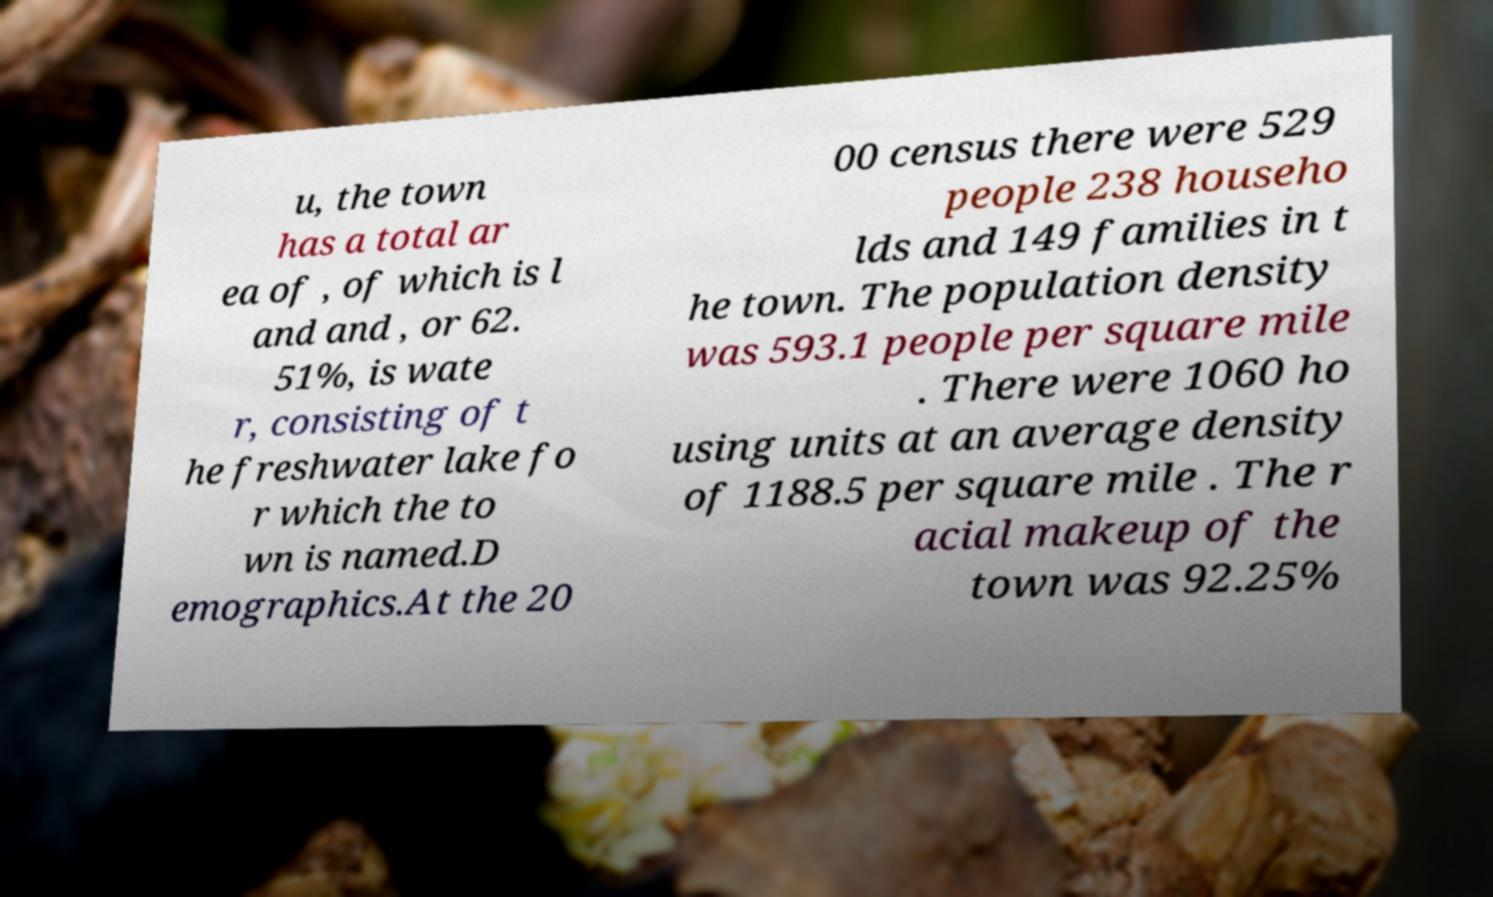What messages or text are displayed in this image? I need them in a readable, typed format. u, the town has a total ar ea of , of which is l and and , or 62. 51%, is wate r, consisting of t he freshwater lake fo r which the to wn is named.D emographics.At the 20 00 census there were 529 people 238 househo lds and 149 families in t he town. The population density was 593.1 people per square mile . There were 1060 ho using units at an average density of 1188.5 per square mile . The r acial makeup of the town was 92.25% 